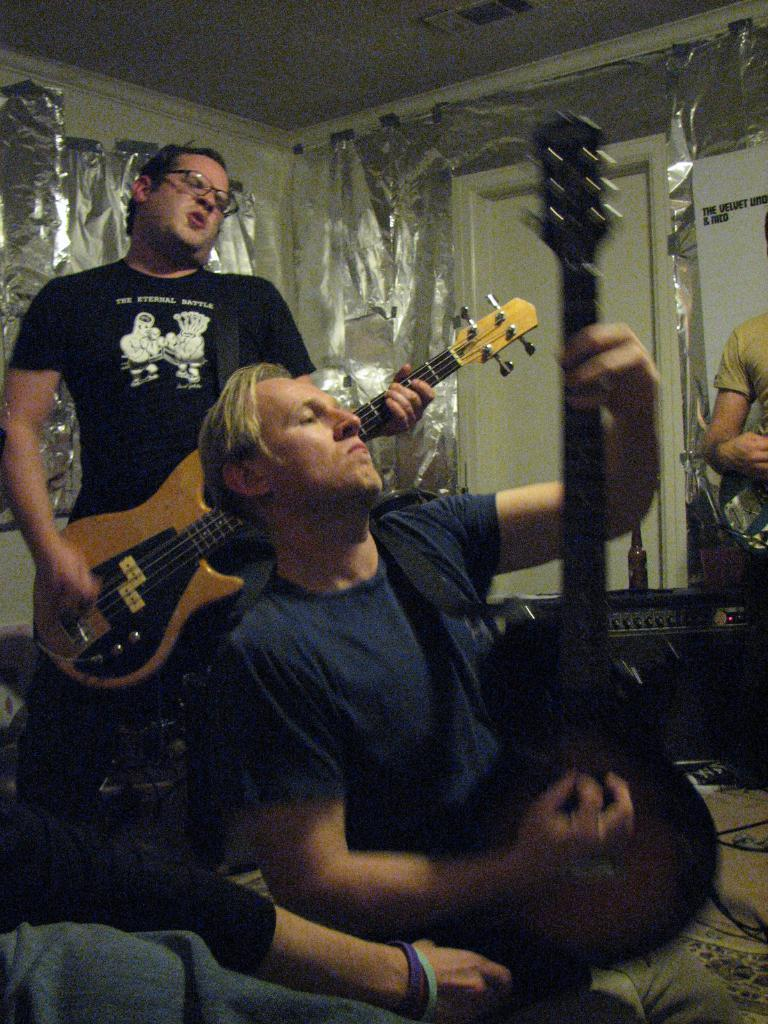How many people are in the image? There are three people in the image. What are the people doing in the image? The people are playing musical instruments. Can you describe any architectural features in the image? Yes, there is a door visible in the image. What type of industry can be seen in the background of the image? There is no industry visible in the image. Is there a whip being used by any of the people in the image? No, there is no whip present in the image. 